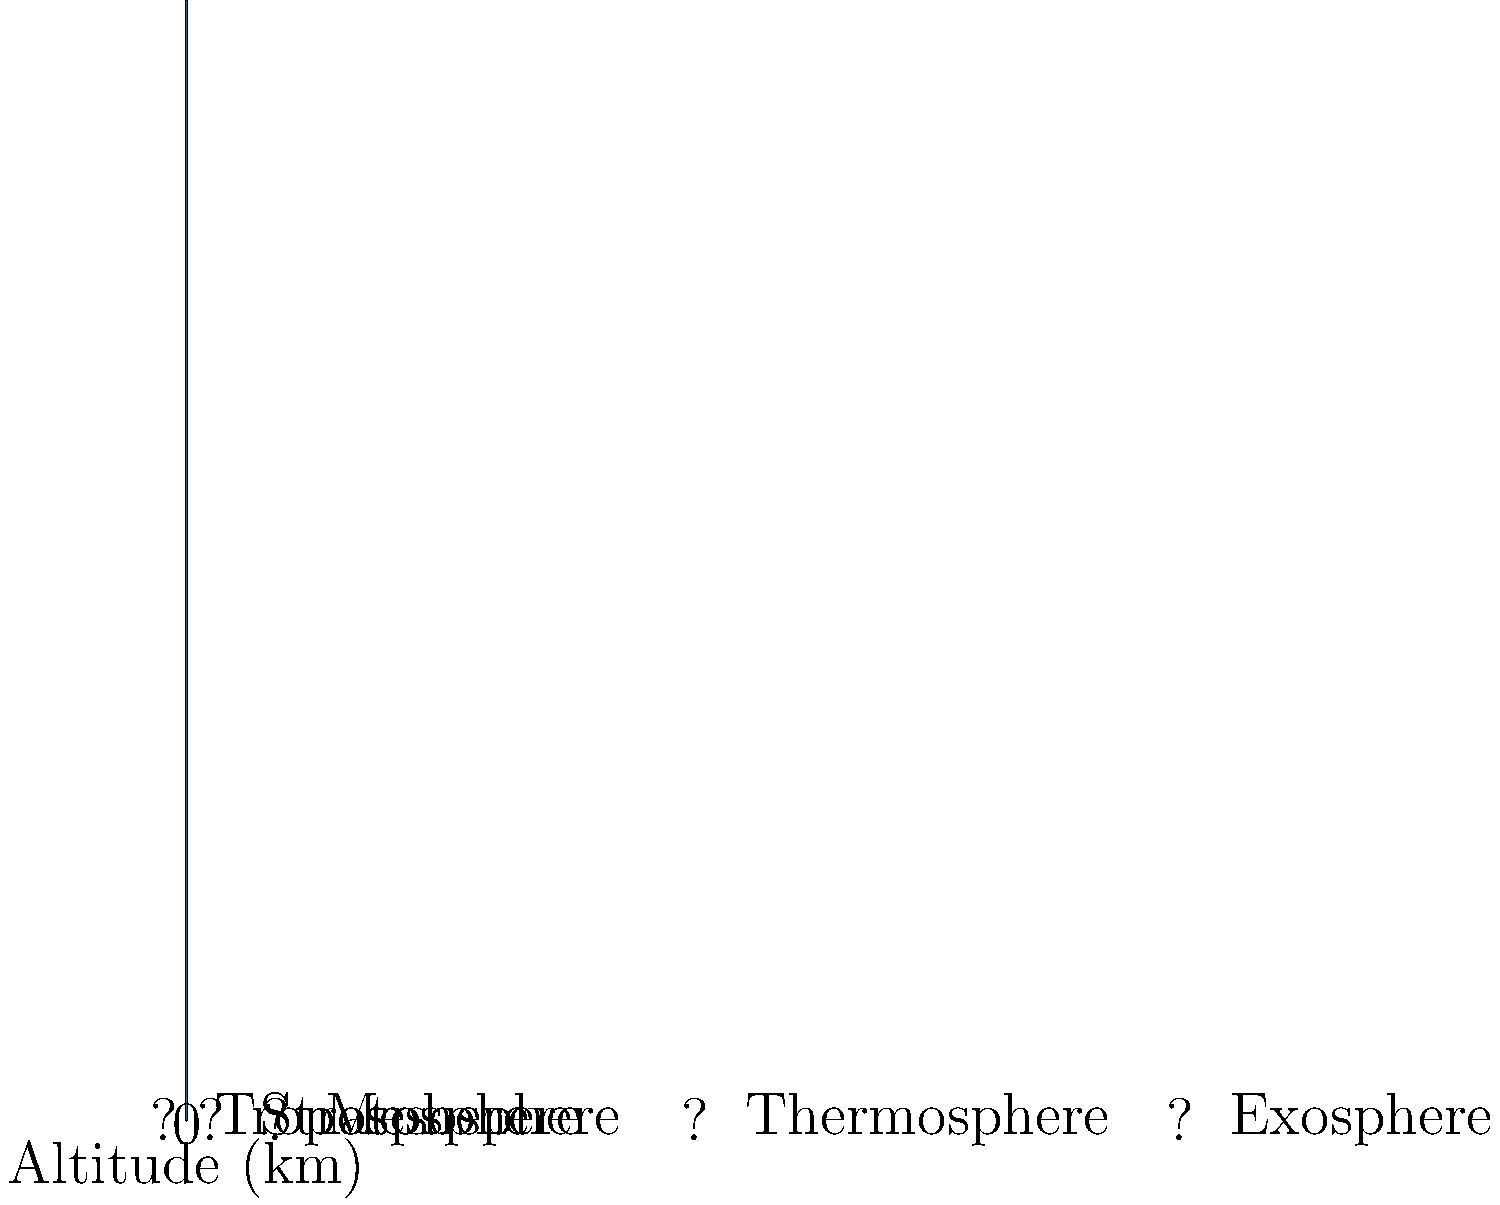As a high school guidance counselor specializing in environmental sciences, you're preparing a lesson on Earth's atmosphere. Using the cross-sectional diagram provided, identify the layers of the atmosphere from bottom to top. Which layer is responsible for most weather phenomena and contains about 80% of the atmosphere's mass? To answer this question, let's analyze the layers of the atmosphere from bottom to top:

1. The first layer, closest to Earth's surface, is the Troposphere. This layer extends from the surface to about 10 km altitude.

2. Above the Troposphere is the Stratosphere, which extends from about 10 km to 50 km altitude.

3. The next layer is the Mesosphere, reaching from 50 km to about 80 km altitude.

4. Above the Mesosphere is the Thermosphere, which extends from 80 km to about 500 km altitude.

5. The outermost layer is the Exosphere, which starts at about 500 km and gradually fades into space.

The layer responsible for most weather phenomena and containing about 80% of the atmosphere's mass is the Troposphere. This is because:

- The Troposphere is the densest layer of the atmosphere, containing most of the atmospheric gases.
- It's where most clouds form and precipitation occurs.
- Temperature generally decreases with altitude in this layer, allowing for vertical mixing and weather patterns.
- It's the layer where we live and where most atmospheric interactions with Earth's surface occur.
Answer: Troposphere 